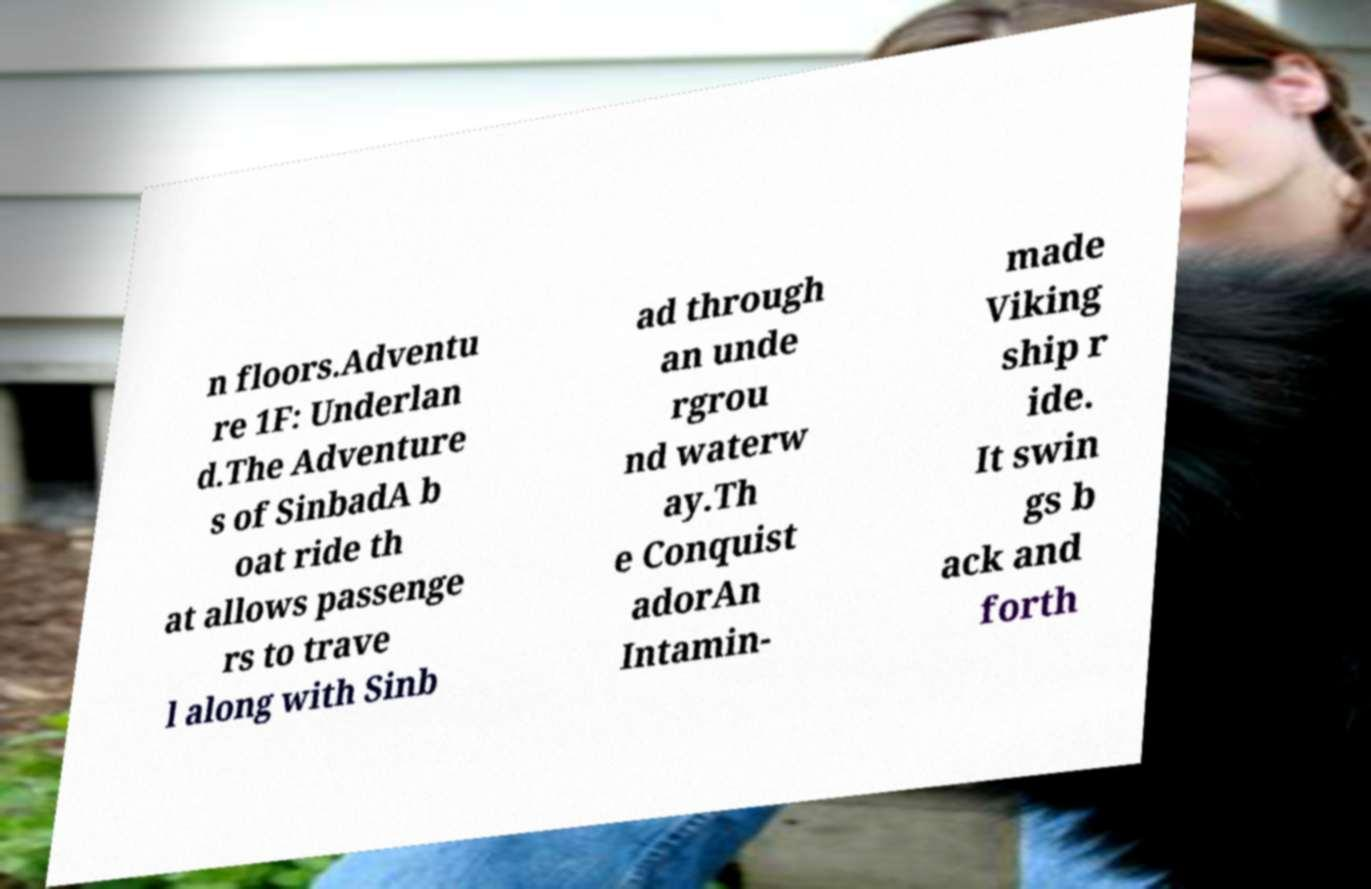Please identify and transcribe the text found in this image. n floors.Adventu re 1F: Underlan d.The Adventure s of SinbadA b oat ride th at allows passenge rs to trave l along with Sinb ad through an unde rgrou nd waterw ay.Th e Conquist adorAn Intamin- made Viking ship r ide. It swin gs b ack and forth 